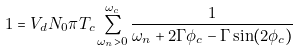<formula> <loc_0><loc_0><loc_500><loc_500>1 = V _ { d } N _ { 0 } \pi T _ { c } \sum _ { \omega _ { n } > 0 } ^ { \omega _ { c } } \frac { 1 } { \omega _ { n } + 2 \Gamma \phi _ { c } - \Gamma \sin ( 2 \phi _ { c } ) }</formula> 